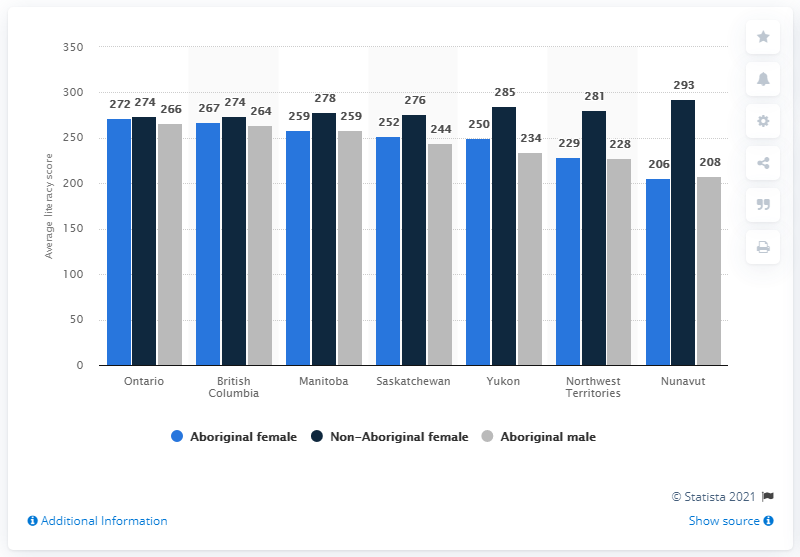Give some essential details in this illustration. In 2012, the average literacy score for Aboriginal women in Ontario, Canada was 272. The use of the color grey in this piece is indicative of an Aboriginal male aesthetic, as it conveys a sense of cultural identity and connection to the land. The average of British Columbia is 268. 